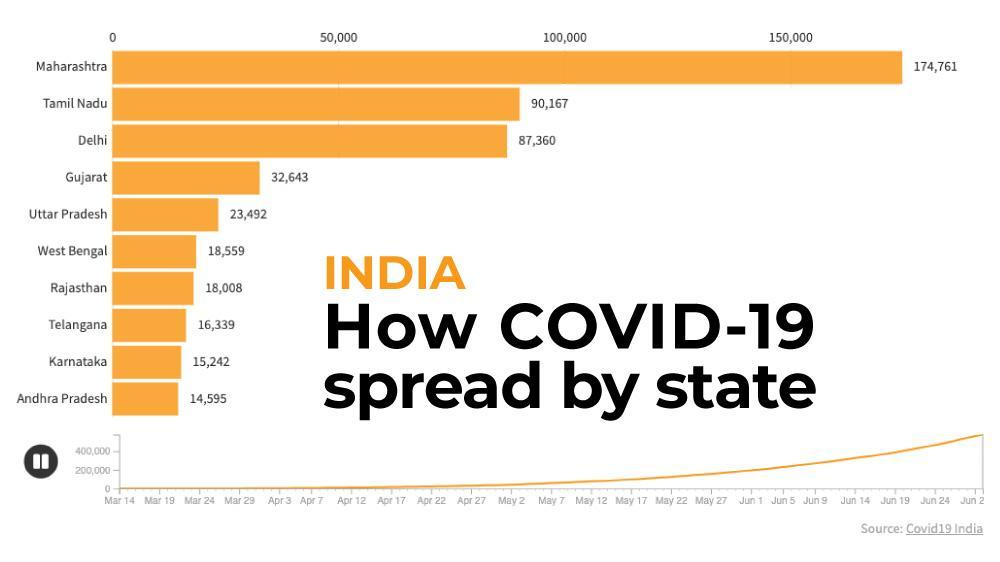What is the number of Covid-19 cases in Karnataka on March 22?
Answer the question with a short phrase. 15,242 What is the number of Covid-19 cases in Gujarat on April 1? 32,643 What is the number of Covid-19 cases in Uttar Pradesh on March 27? 23,492 What is the number of Covid-19 cases in Tamil Nadu on May 4? 90,167 What is the number of Covid-19 cases in Telangana on March 23? 16,339 